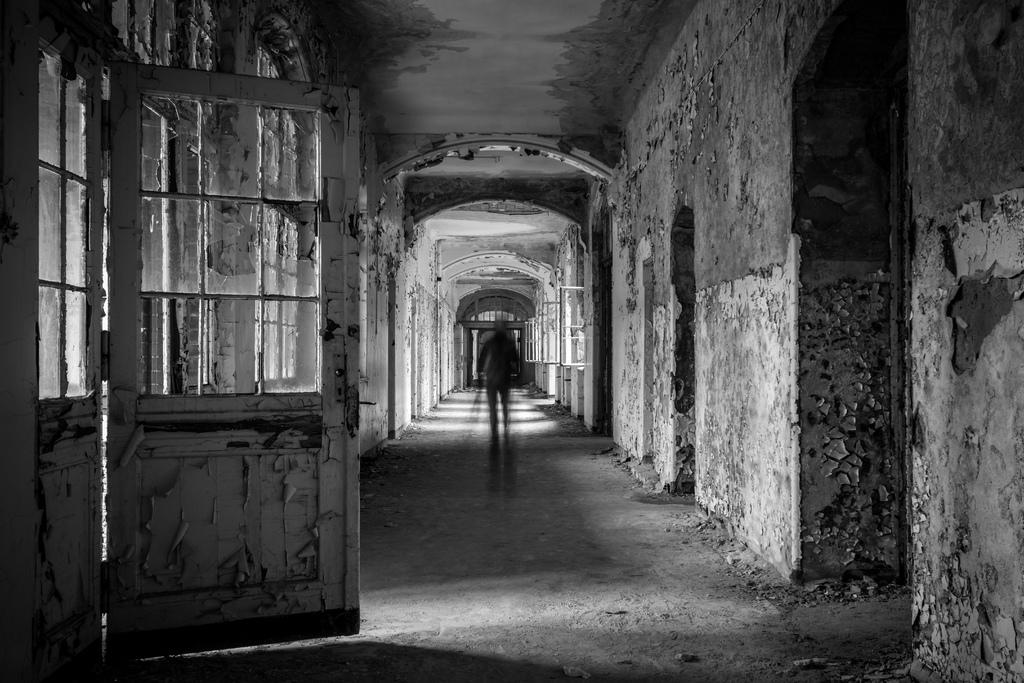What is the main subject of the image? There is a person standing inside the building. How is the person depicted in the image? The person is blurred. What is located to the left of the person? There is a door to the left of the person. What color scheme is used in the image? The image is black and white. What type of button can be seen on the person's shirt in the image? There is no button visible on the person's shirt in the image, as the person is blurred and the image is black and white. Can you describe the net that is hanging from the ceiling in the image? There is no net present in the image; it only features a person standing inside a building with a door to the left. 